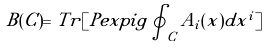Convert formula to latex. <formula><loc_0><loc_0><loc_500><loc_500>B ( C ) = T r [ P e x p i \tilde { g } \oint _ { C } \tilde { A } _ { i } ( x ) d x ^ { i } ]</formula> 